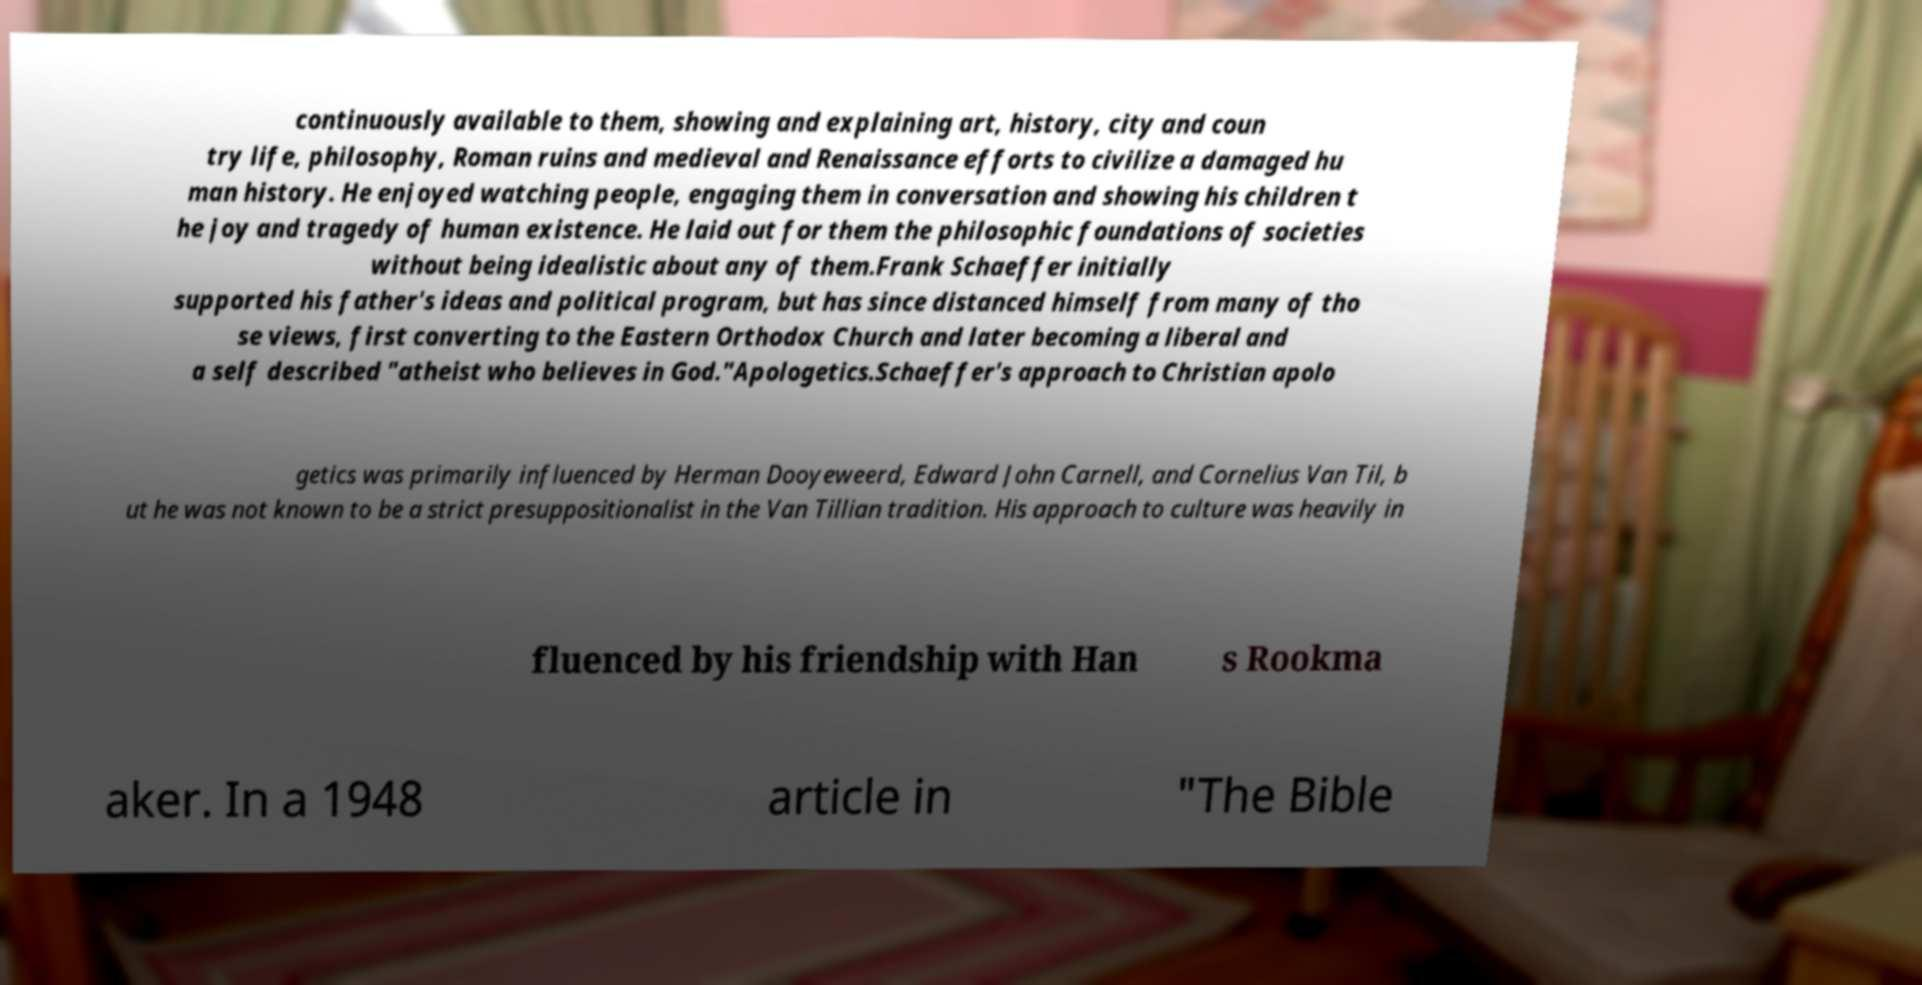Can you read and provide the text displayed in the image?This photo seems to have some interesting text. Can you extract and type it out for me? continuously available to them, showing and explaining art, history, city and coun try life, philosophy, Roman ruins and medieval and Renaissance efforts to civilize a damaged hu man history. He enjoyed watching people, engaging them in conversation and showing his children t he joy and tragedy of human existence. He laid out for them the philosophic foundations of societies without being idealistic about any of them.Frank Schaeffer initially supported his father's ideas and political program, but has since distanced himself from many of tho se views, first converting to the Eastern Orthodox Church and later becoming a liberal and a self described "atheist who believes in God."Apologetics.Schaeffer's approach to Christian apolo getics was primarily influenced by Herman Dooyeweerd, Edward John Carnell, and Cornelius Van Til, b ut he was not known to be a strict presuppositionalist in the Van Tillian tradition. His approach to culture was heavily in fluenced by his friendship with Han s Rookma aker. In a 1948 article in "The Bible 